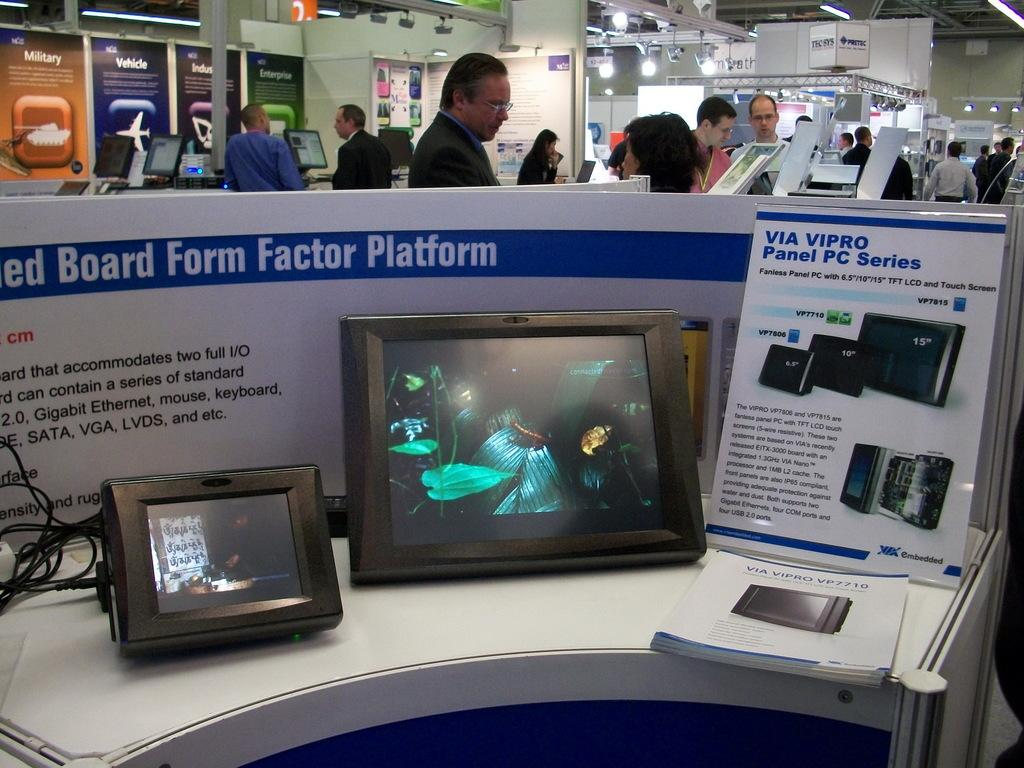<image>
Describe the image concisely. A display of VIA VIPRO Panel PC Series. 